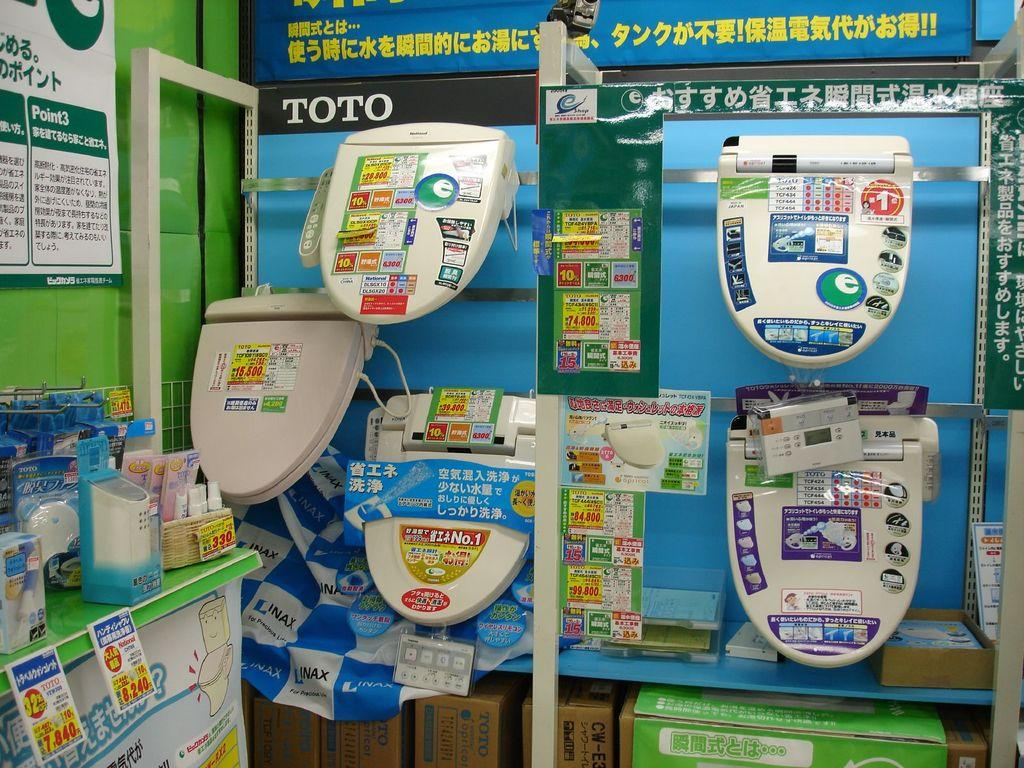<image>
Share a concise interpretation of the image provided. A lot of toilet lids hanging on a display with the word Toto nearby. 